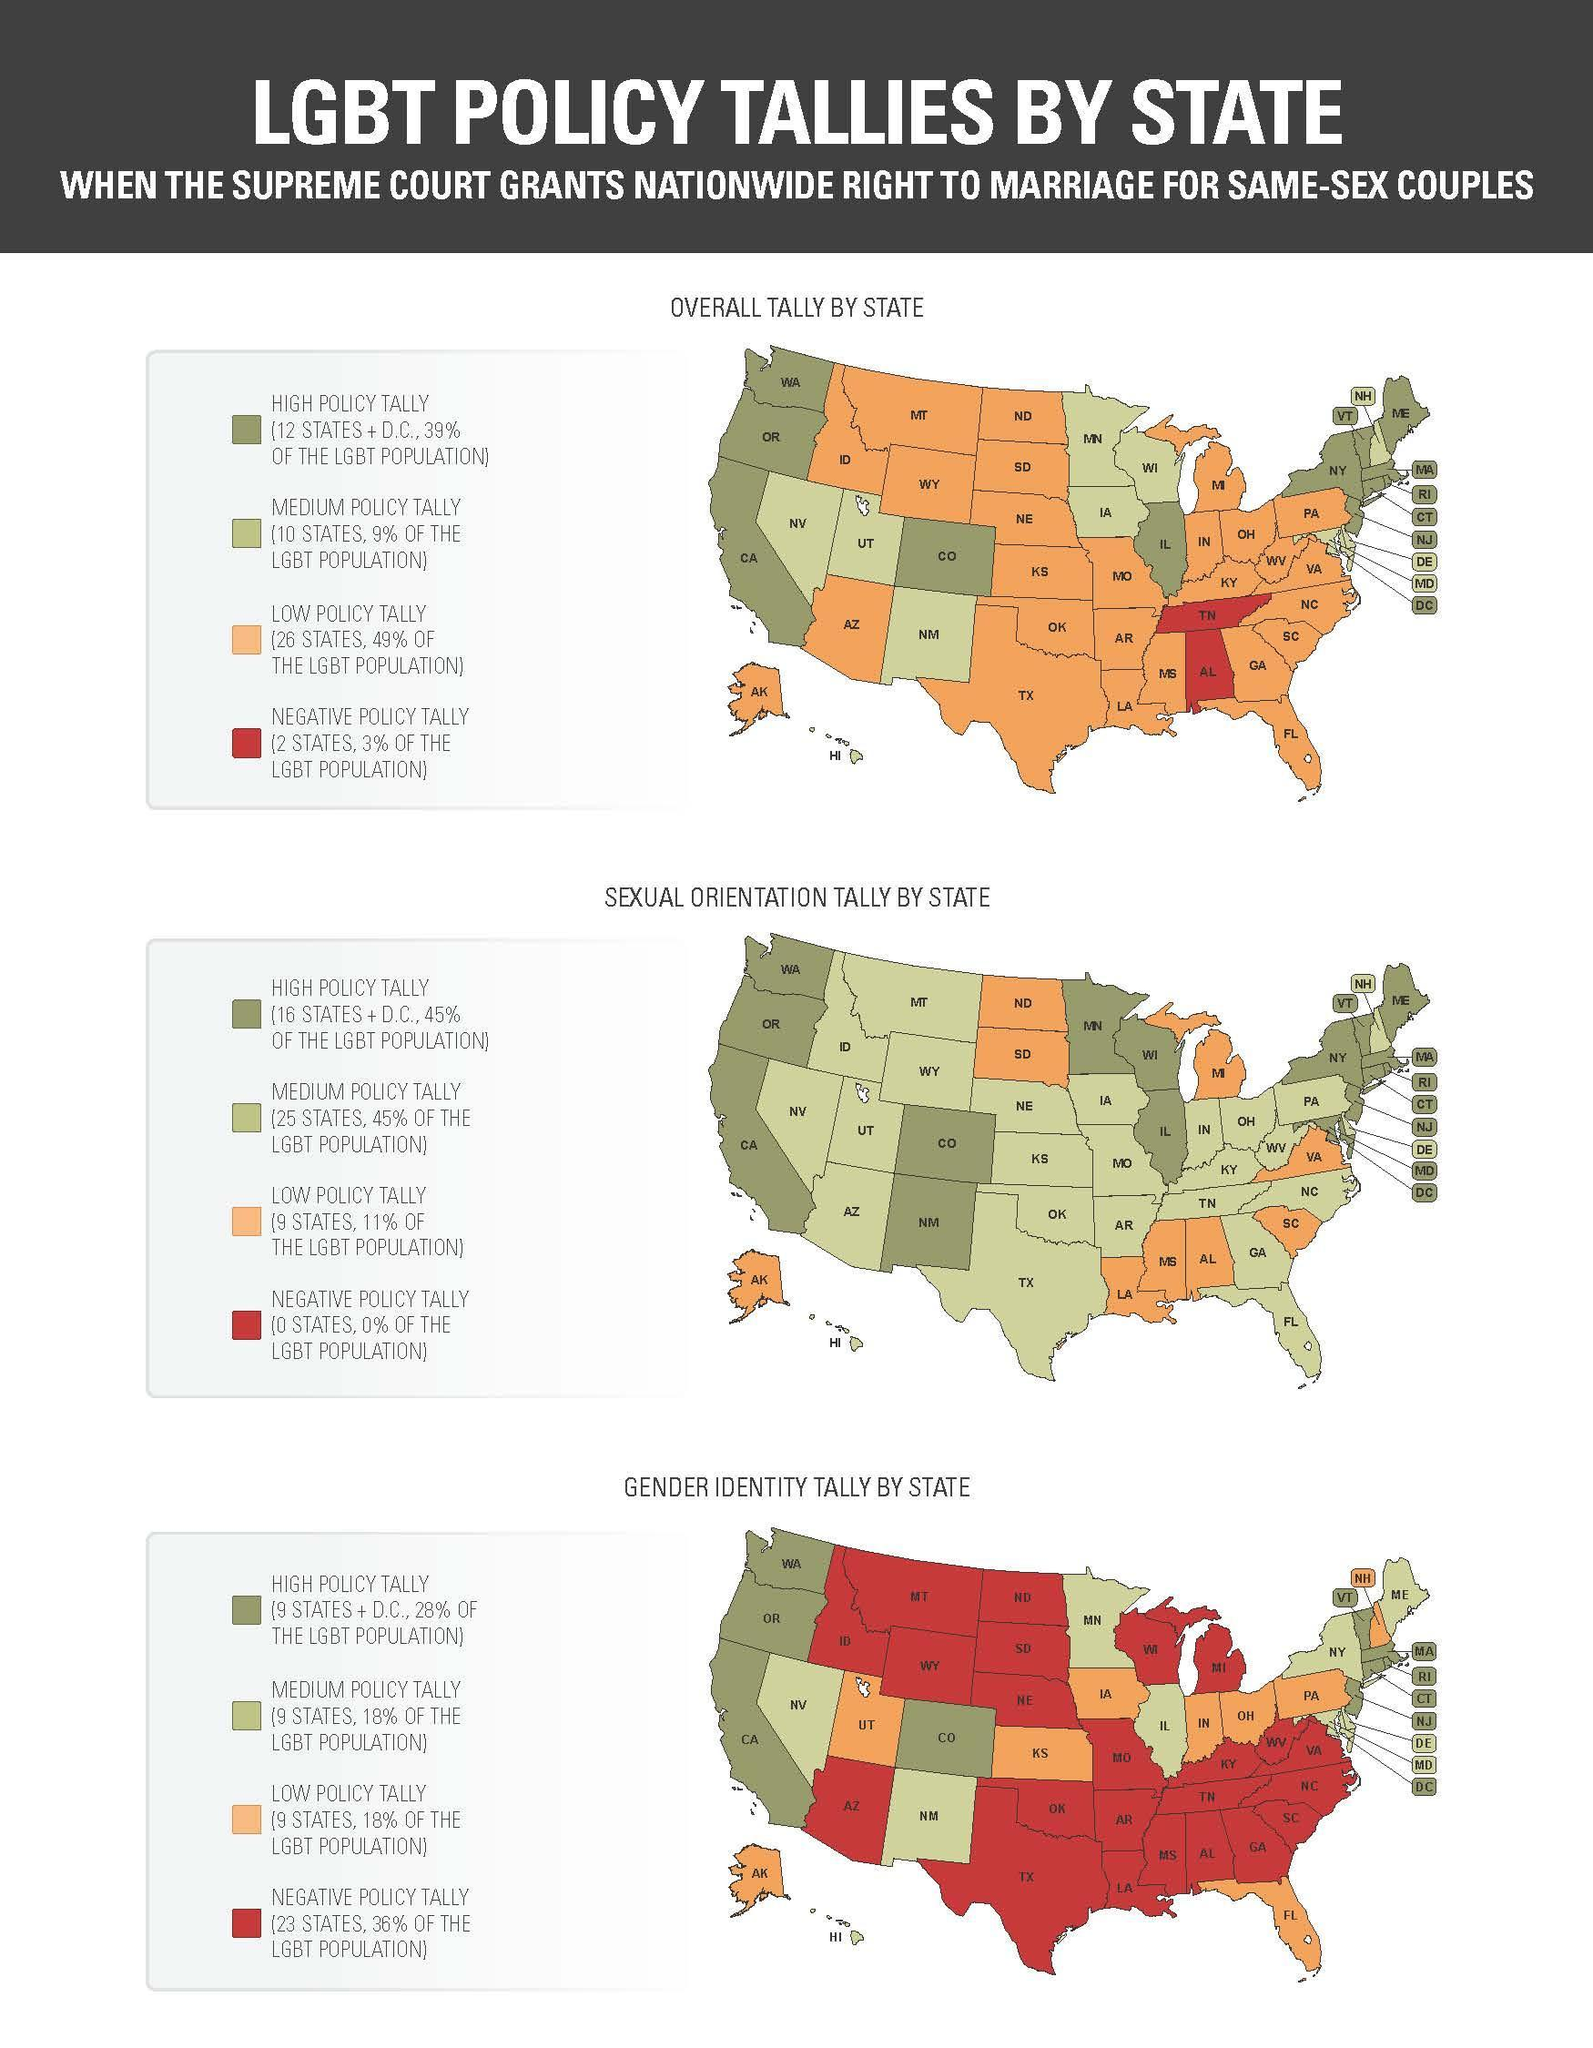As per overall tally by state, which island has low policy tally
Answer the question with a short phrase. AK As per sexual orientation tally by state, which island as low policy tally AK As per gender identity tally by state, which island has low policy tally AK As per overall tally by state, which states have negative policy tally TN, AL 